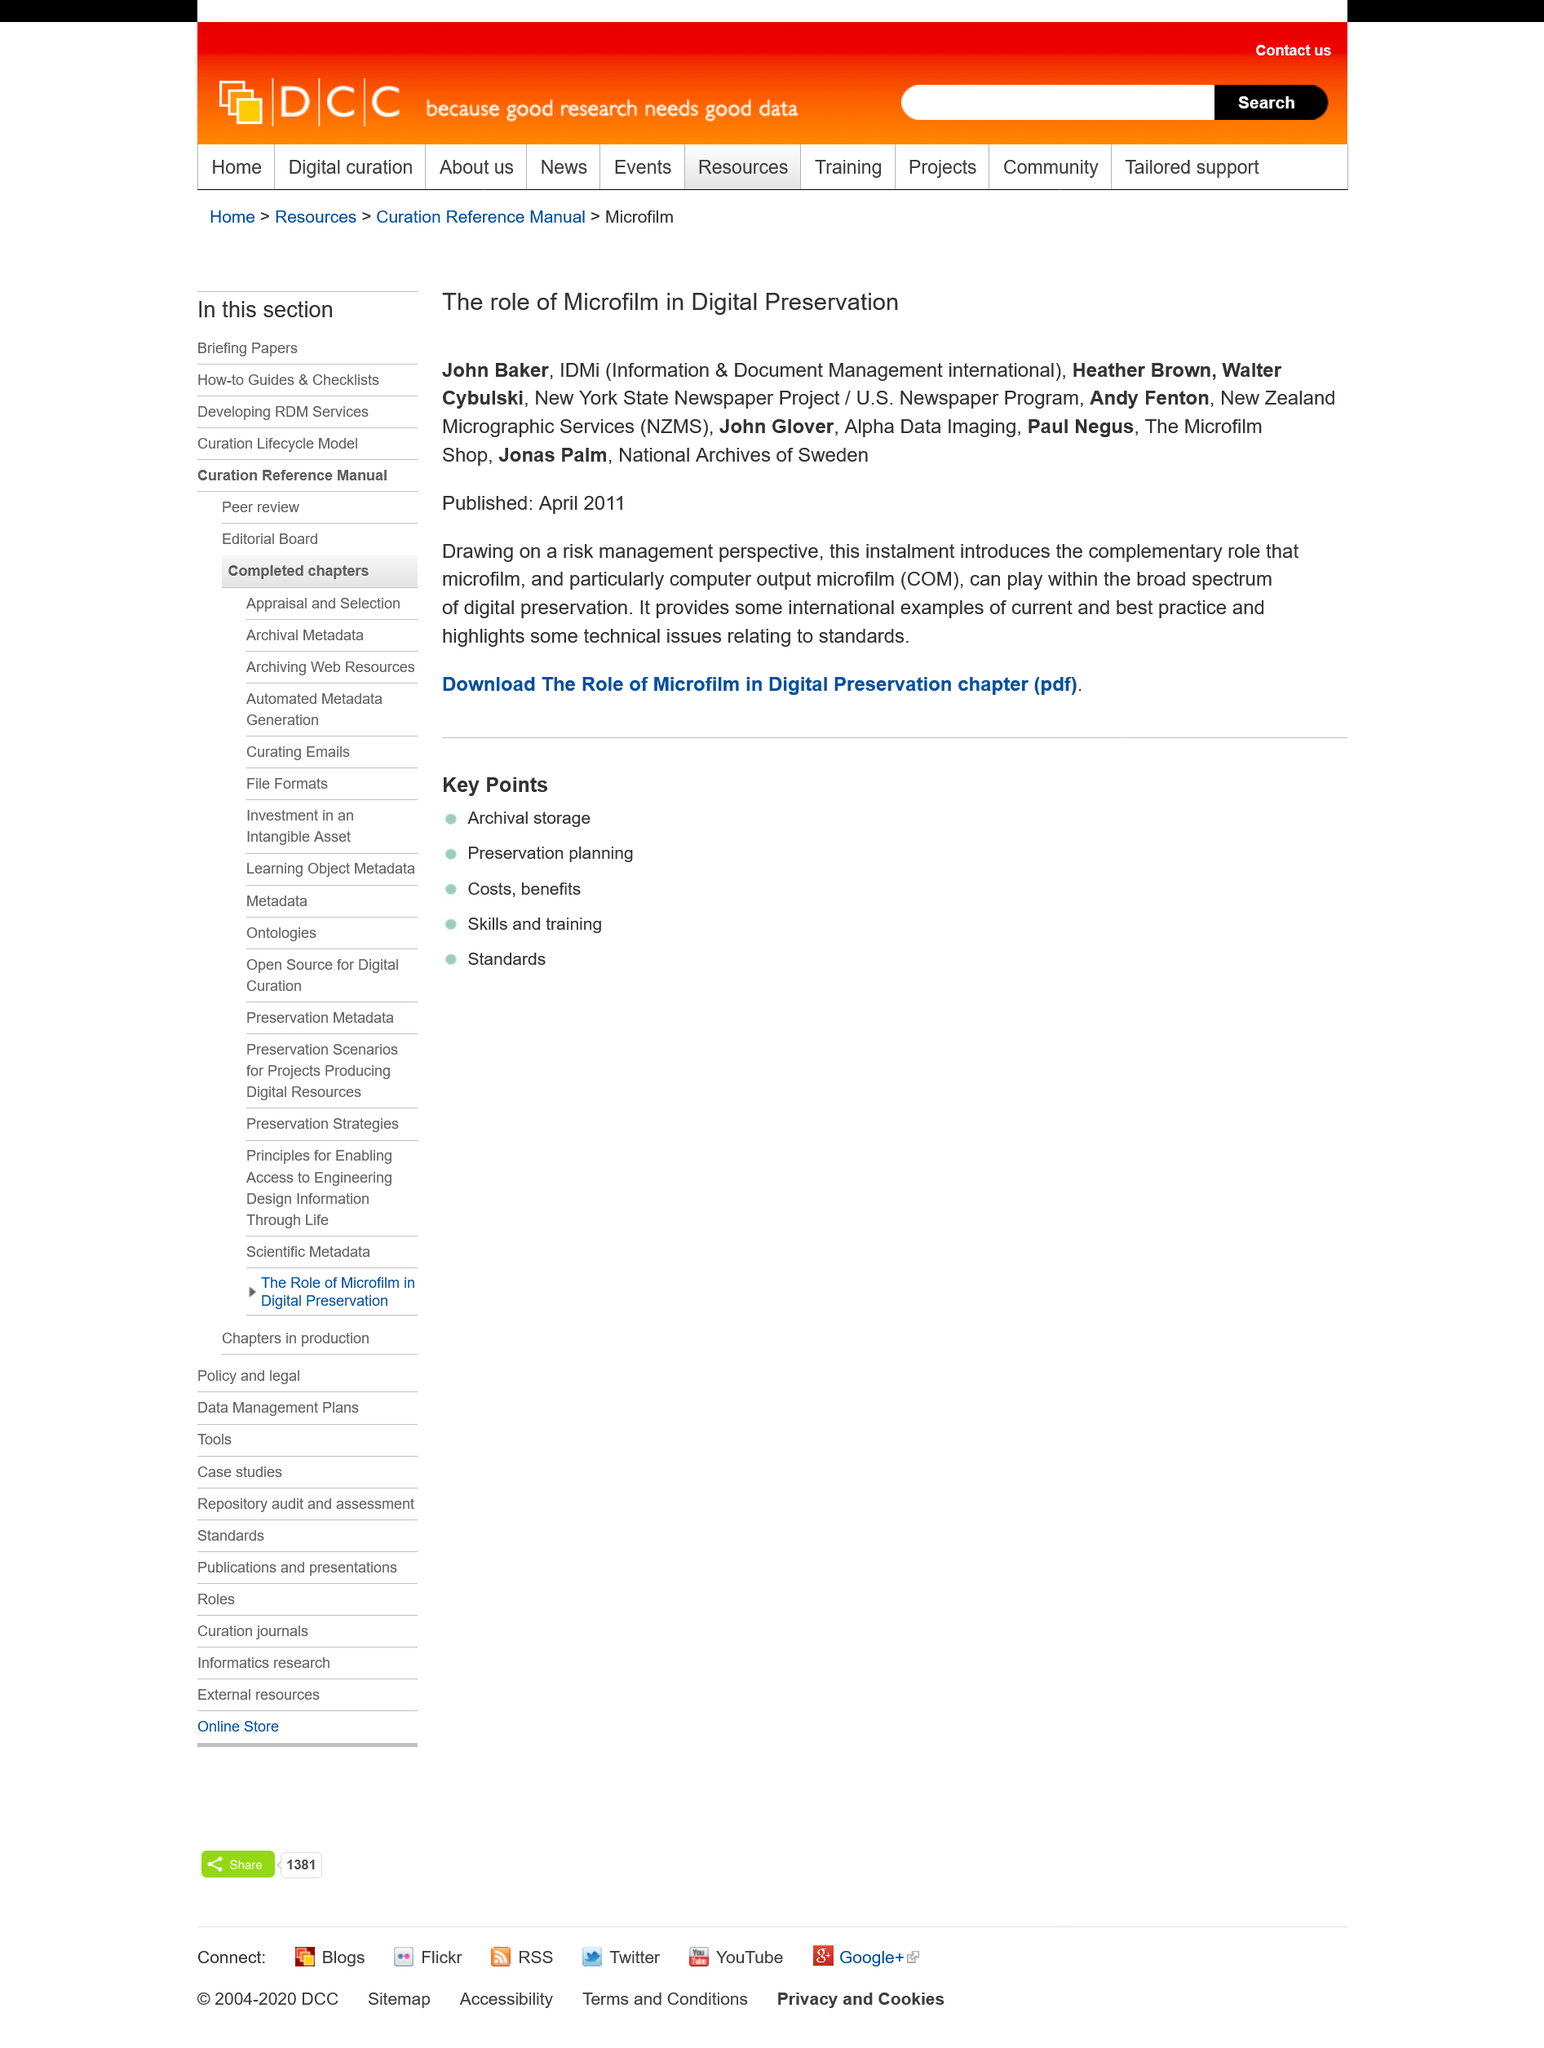Draw attention to some important aspects in this diagram. The article was published in April 2011. COM is an acronym that stands for "computer output microfilm. The article provides some international examples of current and best practice, as it highlights the importance of providing opportunities for student voice and agency in digital environments. 